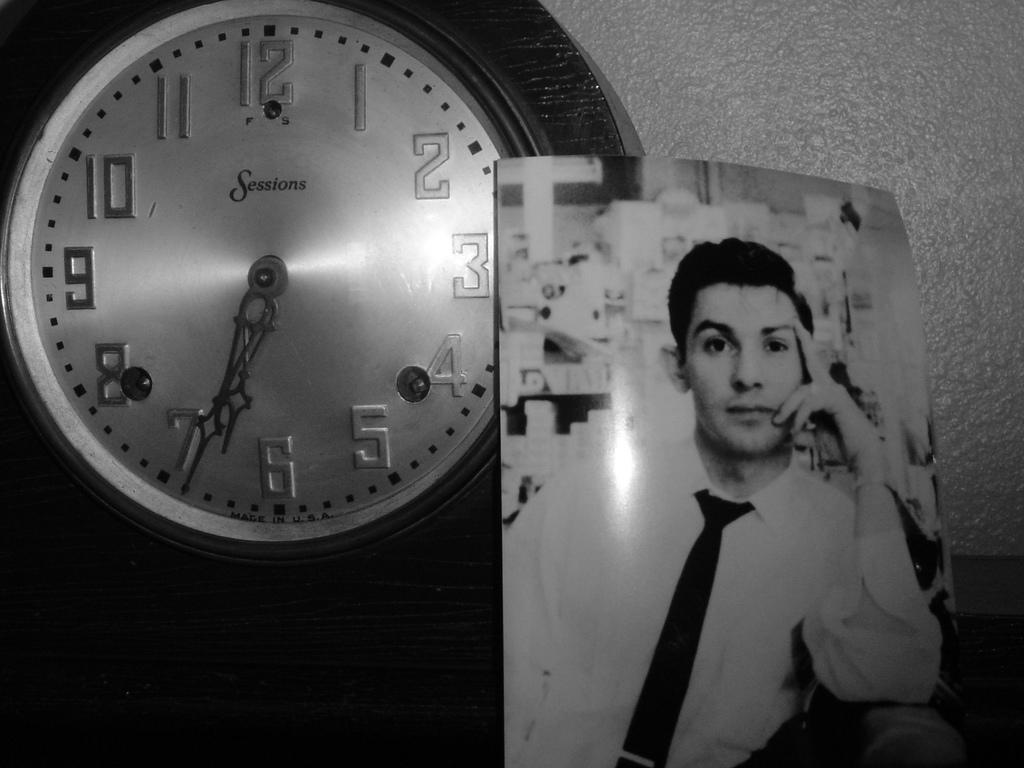What object in the picture indicates the time? There is a clock in the picture that indicates the time. Where is the clock located in relation to other objects in the picture? The clock is near a wall in the picture. What can be seen in the picture besides the clock? There is a photograph of a man in the picture. How is the man in the photograph dressed? The man in the photograph is wearing a white shirt and a tie. What type of fork can be seen in the man's hand in the photograph? There is no fork visible in the photograph of the man; he is not holding any utensils. 